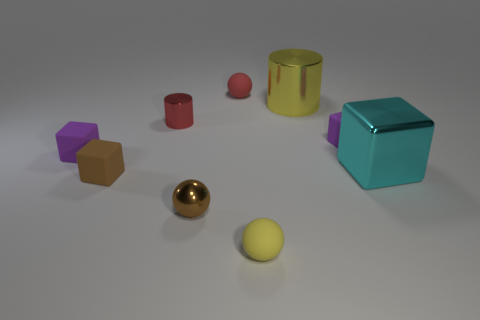Subtract all tiny rubber cubes. How many cubes are left? 1 Subtract all gray spheres. How many purple cubes are left? 2 Subtract 2 blocks. How many blocks are left? 2 Subtract all cyan cubes. How many cubes are left? 3 Subtract all green spheres. Subtract all red cylinders. How many spheres are left? 3 Add 1 small purple rubber things. How many objects exist? 10 Subtract all cylinders. How many objects are left? 7 Subtract all big yellow metal cubes. Subtract all small brown matte things. How many objects are left? 8 Add 3 brown blocks. How many brown blocks are left? 4 Add 1 small gray metal blocks. How many small gray metal blocks exist? 1 